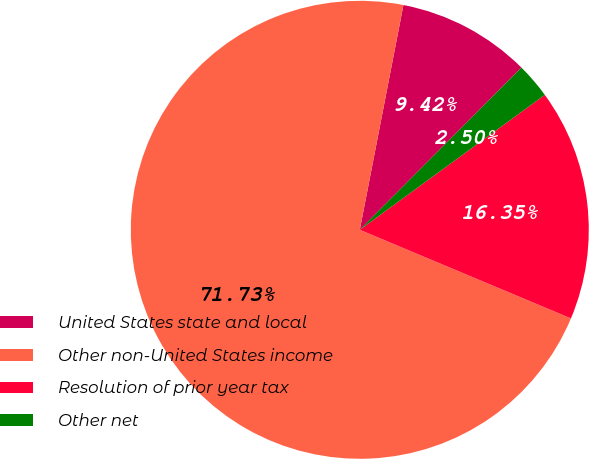Convert chart to OTSL. <chart><loc_0><loc_0><loc_500><loc_500><pie_chart><fcel>United States state and local<fcel>Other non-United States income<fcel>Resolution of prior year tax<fcel>Other net<nl><fcel>9.42%<fcel>71.73%<fcel>16.35%<fcel>2.5%<nl></chart> 